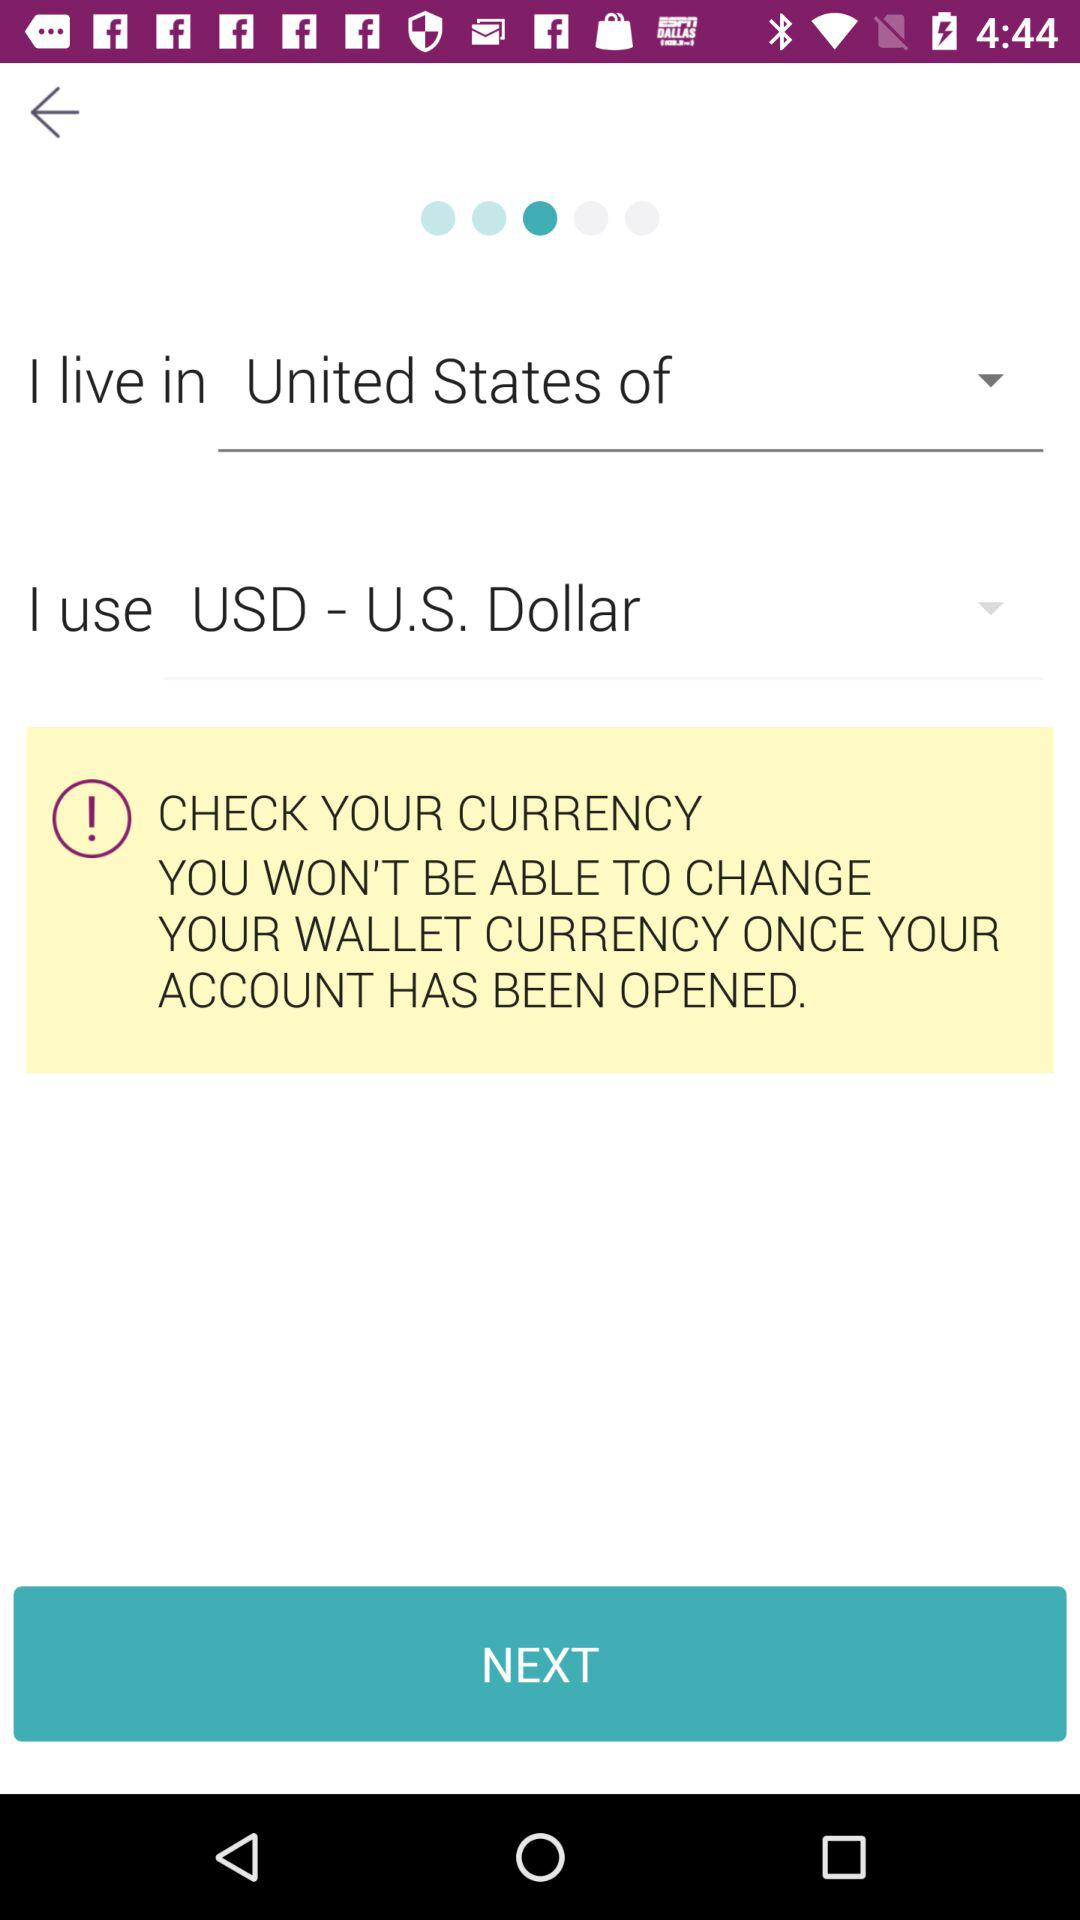What is the selected currency? The selected currency is "USD - U.S. Dollar". 